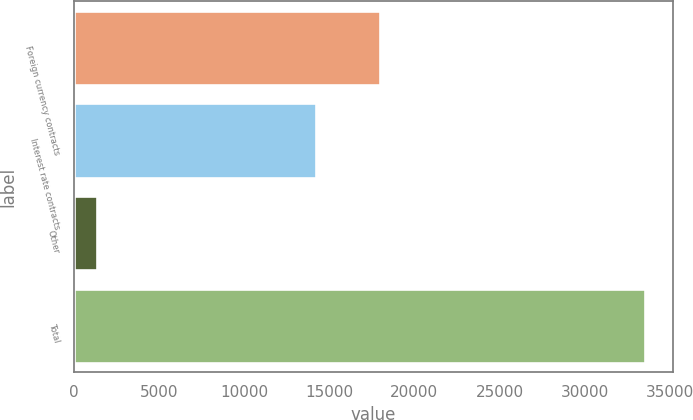Convert chart to OTSL. <chart><loc_0><loc_0><loc_500><loc_500><bar_chart><fcel>Foreign currency contracts<fcel>Interest rate contracts<fcel>Other<fcel>Total<nl><fcel>17960<fcel>14228<fcel>1340<fcel>33528<nl></chart> 